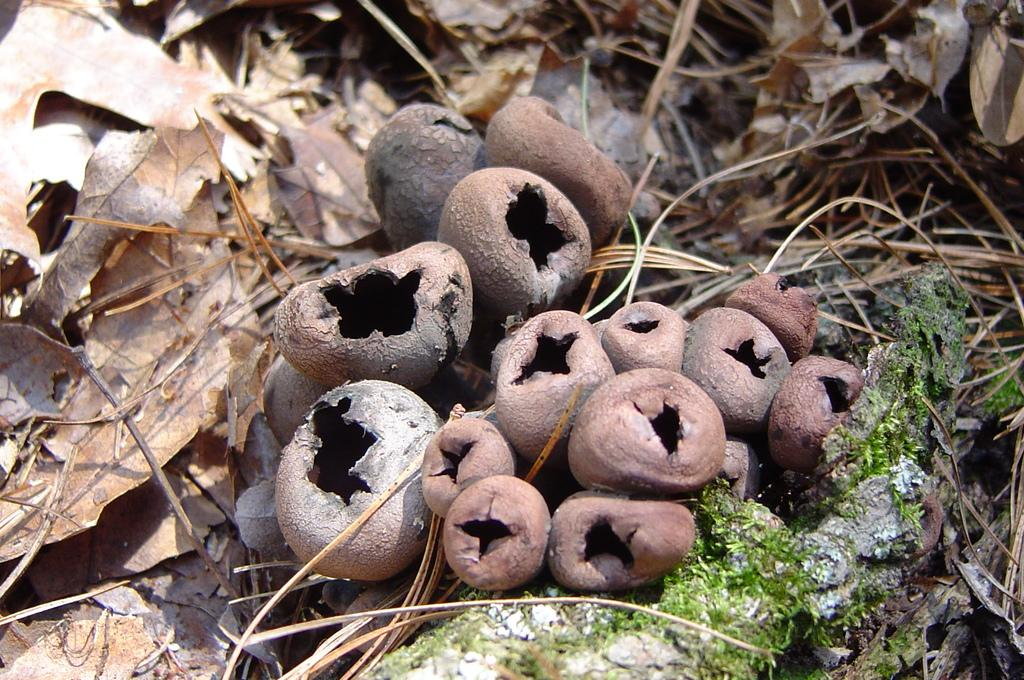What type of objects are present in the image? There are dry objects in the image. What is a characteristic of these dry objects? The dry objects have holes. What color are the dry objects? The dry objects are in brown color. What other dry items can be seen in the image? There are dry leaves in the image. Can you see a rake being used to gather the dry objects in the image? There is no rake present in the image, and the dry objects are not being gathered. Is there a donkey in the image? There is no donkey present in the image. 